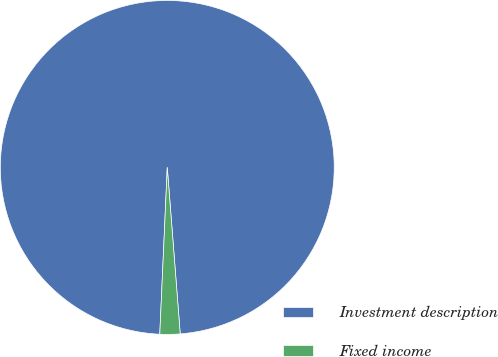Convert chart to OTSL. <chart><loc_0><loc_0><loc_500><loc_500><pie_chart><fcel>Investment description<fcel>Fixed income<nl><fcel>98.05%<fcel>1.95%<nl></chart> 